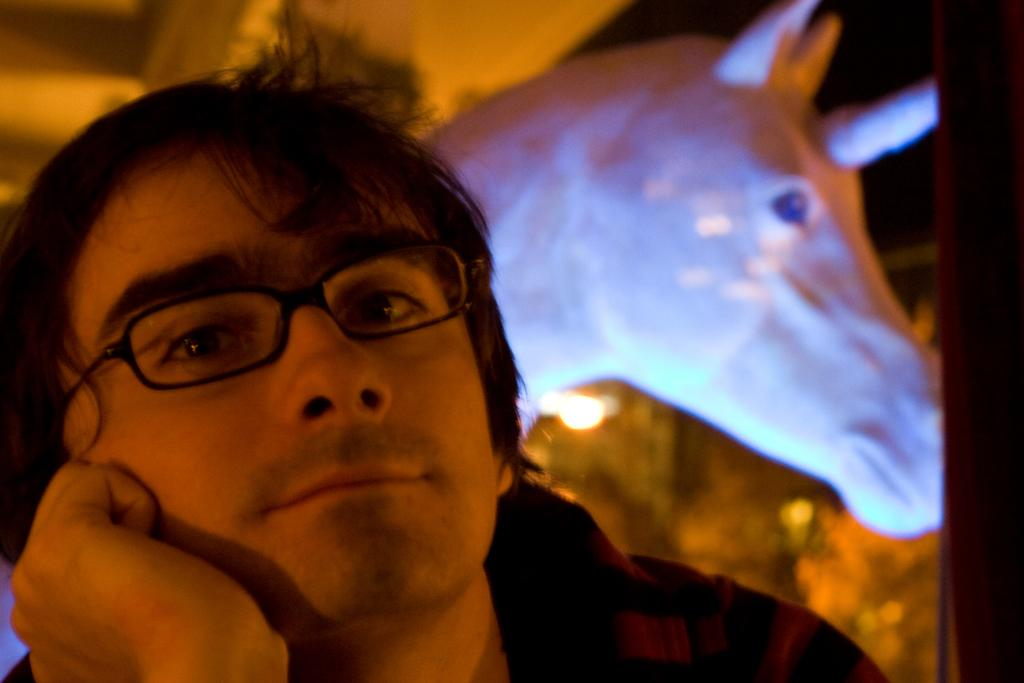Who is present in the image? There is a man in the image. What is the man wearing on his upper body? The man is wearing a shirt. What accessory is the man wearing on his face? The man is wearing spectacles. What can be seen in the background of the image? There is a statue of a horse in the background of the image. What type of cast can be seen on the man's leg in the image? There is no cast visible on the man's leg in the image. What kind of vessel is the man holding in the image? The man is not holding any vessel in the image. 